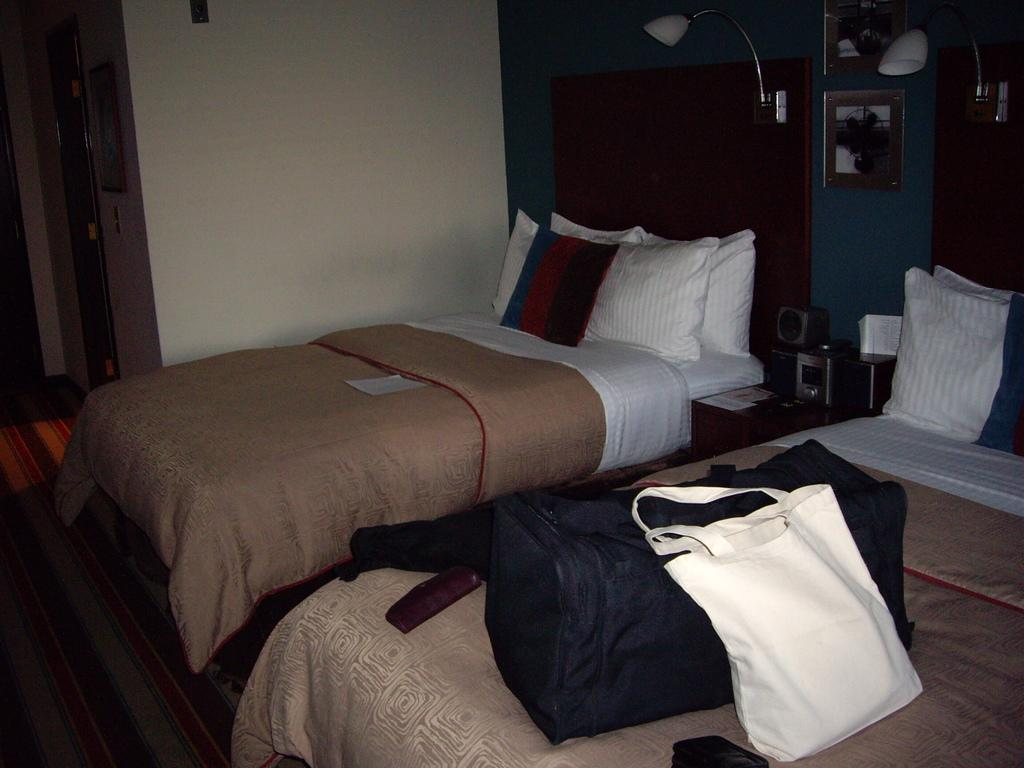How many beds are present in the image? There are two beds in the image. What is placed on both beds? Bags and pillows are placed on both beds. Can you describe the additional item on one of the beds? There is a paper on one of the beds. What can be used for personal grooming or checking appearance in the image? There is a mirror in the image. What provides illumination in the image? There is a light in the image. What type of lace can be seen on the bedspreads in the image? There is no lace visible on the bedspreads in the image. How many branches are present in the image? There are no branches present in the image. 